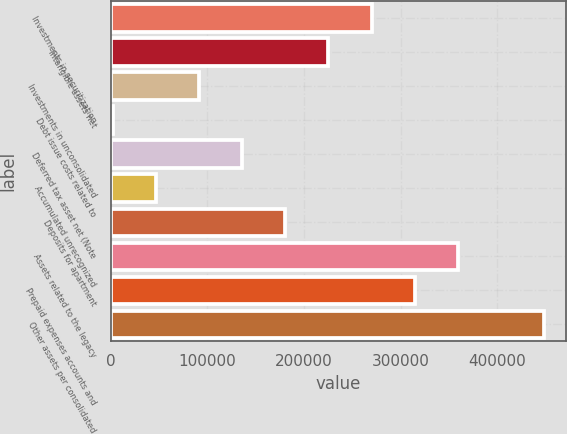Convert chart to OTSL. <chart><loc_0><loc_0><loc_500><loc_500><bar_chart><fcel>Investments in securitization<fcel>Intangible assets net<fcel>Investments in unconsolidated<fcel>Debt issue costs related to<fcel>Deferred tax asset net (Note<fcel>Accumulated unrecognized<fcel>Deposits for apartment<fcel>Assets related to the legacy<fcel>Prepaid expenses accounts and<fcel>Other assets per consolidated<nl><fcel>269886<fcel>225256<fcel>91366.6<fcel>2107<fcel>135996<fcel>46736.8<fcel>180626<fcel>359145<fcel>314516<fcel>448405<nl></chart> 